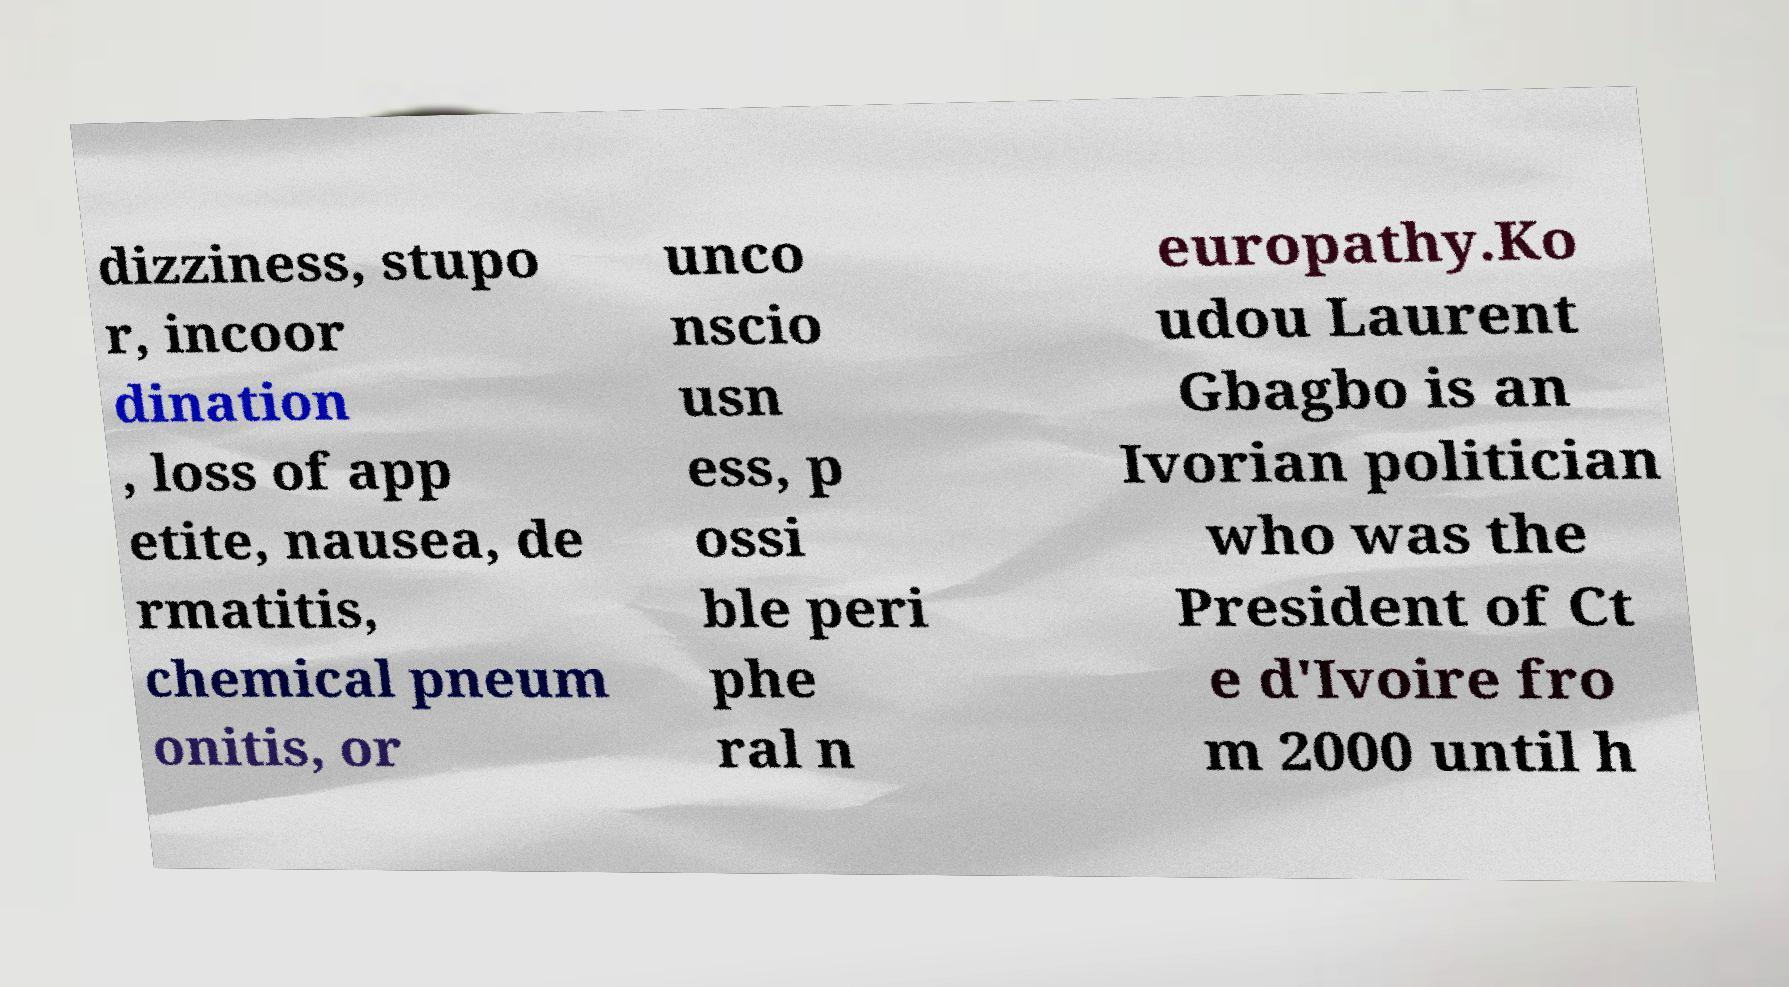What messages or text are displayed in this image? I need them in a readable, typed format. dizziness, stupo r, incoor dination , loss of app etite, nausea, de rmatitis, chemical pneum onitis, or unco nscio usn ess, p ossi ble peri phe ral n europathy.Ko udou Laurent Gbagbo is an Ivorian politician who was the President of Ct e d'Ivoire fro m 2000 until h 